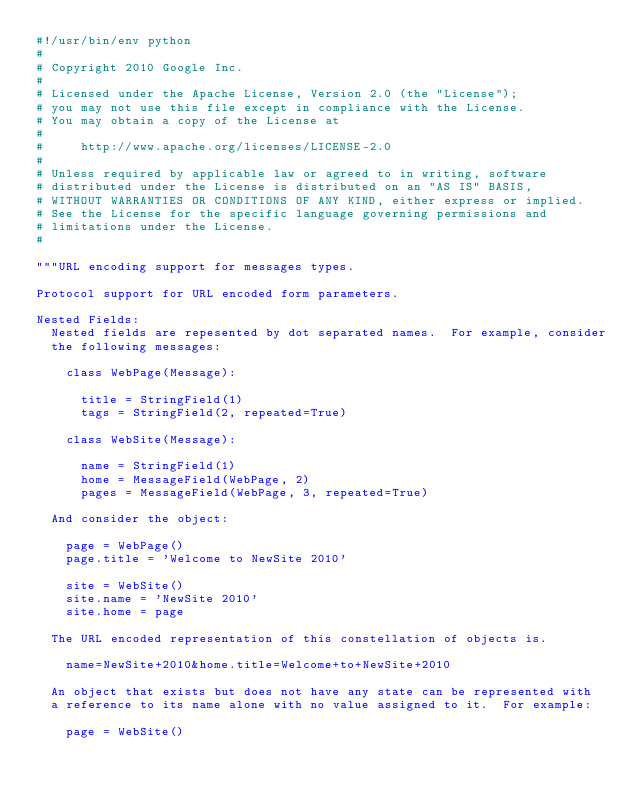<code> <loc_0><loc_0><loc_500><loc_500><_Python_>#!/usr/bin/env python
#
# Copyright 2010 Google Inc.
#
# Licensed under the Apache License, Version 2.0 (the "License");
# you may not use this file except in compliance with the License.
# You may obtain a copy of the License at
#
#     http://www.apache.org/licenses/LICENSE-2.0
#
# Unless required by applicable law or agreed to in writing, software
# distributed under the License is distributed on an "AS IS" BASIS,
# WITHOUT WARRANTIES OR CONDITIONS OF ANY KIND, either express or implied.
# See the License for the specific language governing permissions and
# limitations under the License.
#

"""URL encoding support for messages types.

Protocol support for URL encoded form parameters.

Nested Fields:
  Nested fields are repesented by dot separated names.  For example, consider
  the following messages:

    class WebPage(Message):

      title = StringField(1)
      tags = StringField(2, repeated=True)

    class WebSite(Message):

      name = StringField(1)
      home = MessageField(WebPage, 2)
      pages = MessageField(WebPage, 3, repeated=True)

  And consider the object:

    page = WebPage()
    page.title = 'Welcome to NewSite 2010'

    site = WebSite()
    site.name = 'NewSite 2010'
    site.home = page

  The URL encoded representation of this constellation of objects is.

    name=NewSite+2010&home.title=Welcome+to+NewSite+2010

  An object that exists but does not have any state can be represented with
  a reference to its name alone with no value assigned to it.  For example:

    page = WebSite()</code> 